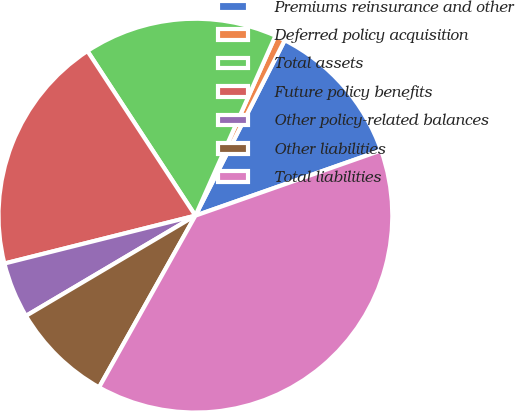<chart> <loc_0><loc_0><loc_500><loc_500><pie_chart><fcel>Premiums reinsurance and other<fcel>Deferred policy acquisition<fcel>Total assets<fcel>Future policy benefits<fcel>Other policy-related balances<fcel>Other liabilities<fcel>Total liabilities<nl><fcel>12.13%<fcel>0.83%<fcel>15.9%<fcel>19.67%<fcel>4.59%<fcel>8.36%<fcel>38.51%<nl></chart> 